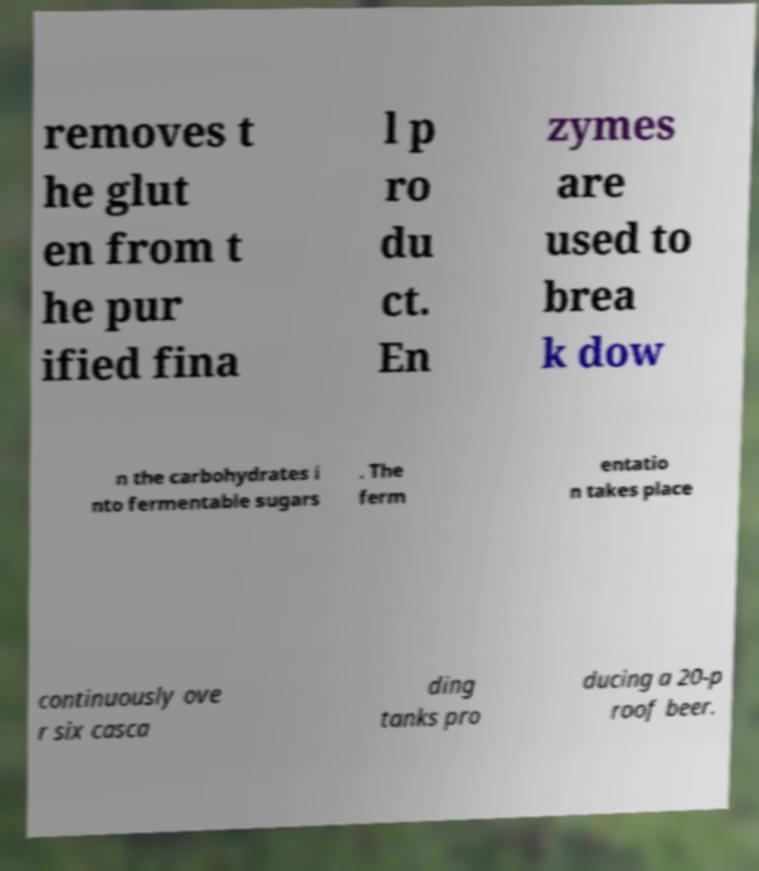Please read and relay the text visible in this image. What does it say? removes t he glut en from t he pur ified fina l p ro du ct. En zymes are used to brea k dow n the carbohydrates i nto fermentable sugars . The ferm entatio n takes place continuously ove r six casca ding tanks pro ducing a 20-p roof beer. 